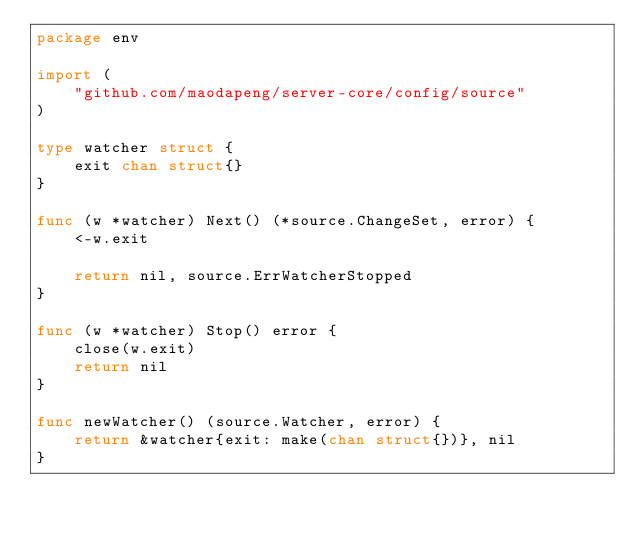<code> <loc_0><loc_0><loc_500><loc_500><_Go_>package env

import (
	"github.com/maodapeng/server-core/config/source"
)

type watcher struct {
	exit chan struct{}
}

func (w *watcher) Next() (*source.ChangeSet, error) {
	<-w.exit

	return nil, source.ErrWatcherStopped
}

func (w *watcher) Stop() error {
	close(w.exit)
	return nil
}

func newWatcher() (source.Watcher, error) {
	return &watcher{exit: make(chan struct{})}, nil
}
</code> 